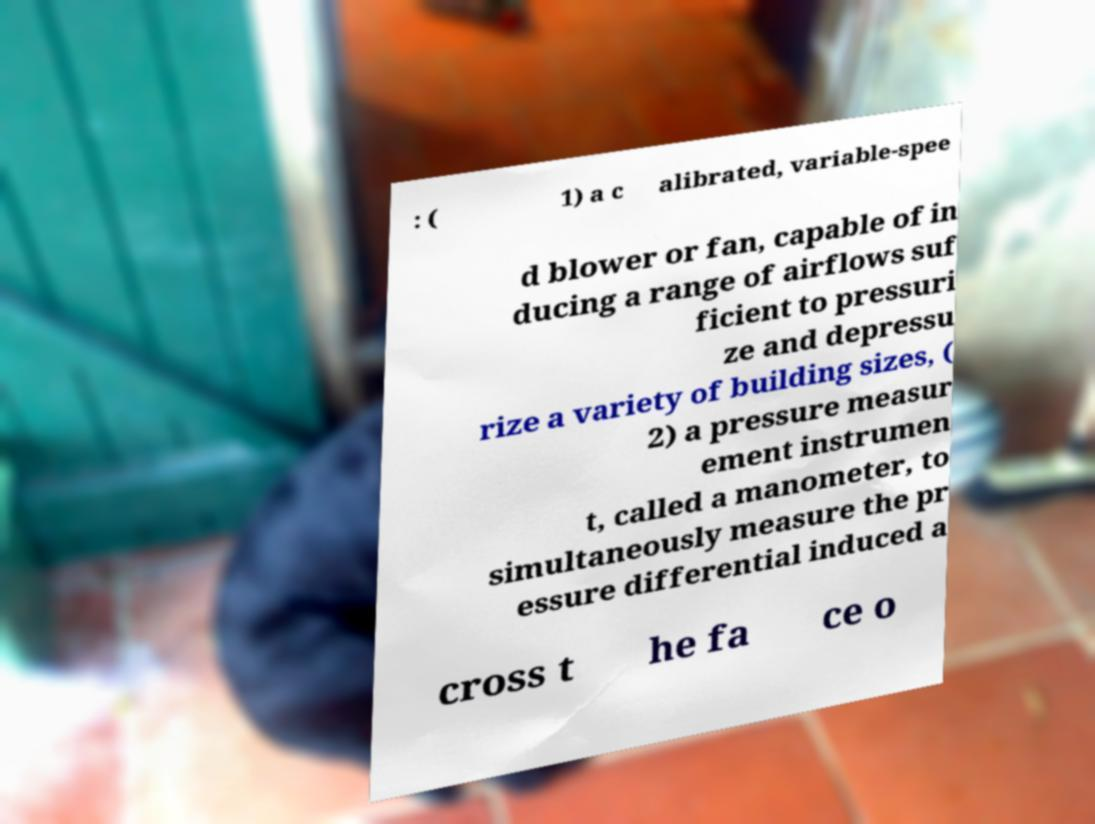I need the written content from this picture converted into text. Can you do that? : ( 1) a c alibrated, variable-spee d blower or fan, capable of in ducing a range of airflows suf ficient to pressuri ze and depressu rize a variety of building sizes, ( 2) a pressure measur ement instrumen t, called a manometer, to simultaneously measure the pr essure differential induced a cross t he fa ce o 